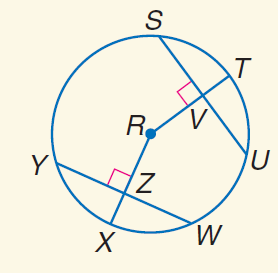Answer the mathemtical geometry problem and directly provide the correct option letter.
Question: In \odot R, S U = 20, Y W = 20, and m \widehat Y X = 45. Find U V.
Choices: A: 10 B: 20 C: 30 D: 45 A 